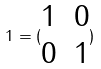Convert formula to latex. <formula><loc_0><loc_0><loc_500><loc_500>1 = ( \begin{matrix} 1 & 0 \\ 0 & 1 \end{matrix} )</formula> 